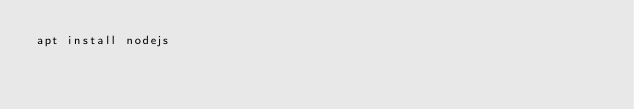Convert code to text. <code><loc_0><loc_0><loc_500><loc_500><_Bash_>apt install nodejs

</code> 